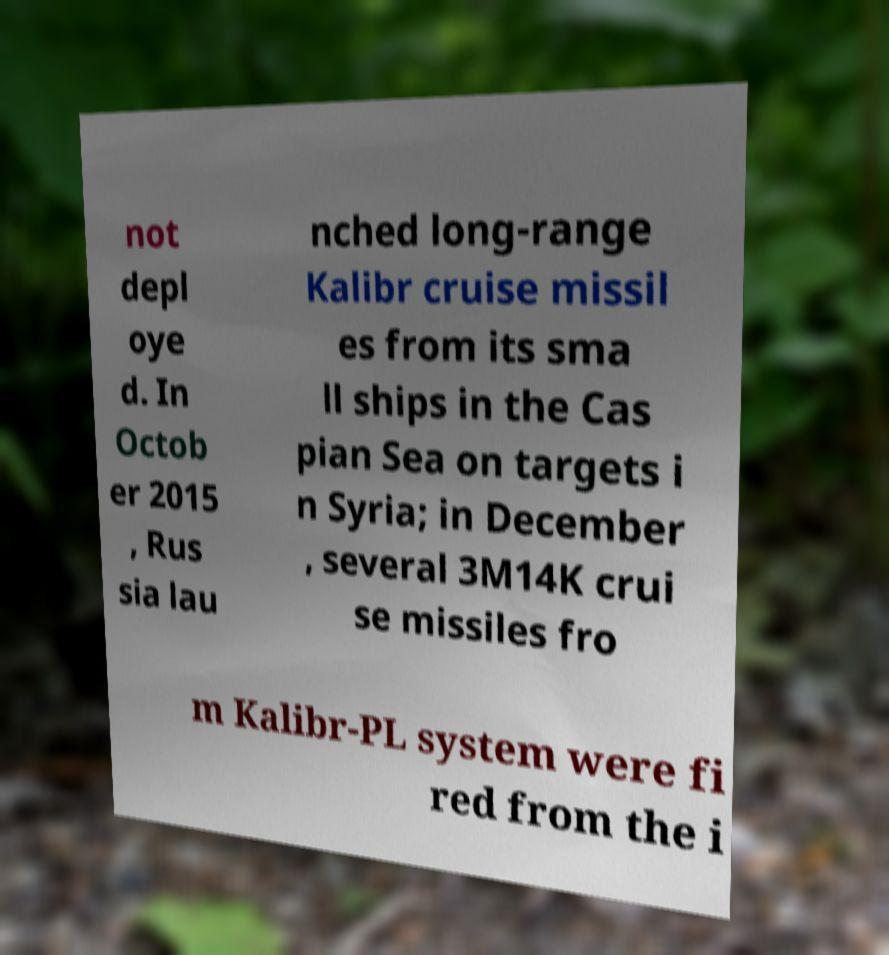Could you extract and type out the text from this image? not depl oye d. In Octob er 2015 , Rus sia lau nched long-range Kalibr cruise missil es from its sma ll ships in the Cas pian Sea on targets i n Syria; in December , several 3M14K crui se missiles fro m Kalibr-PL system were fi red from the i 